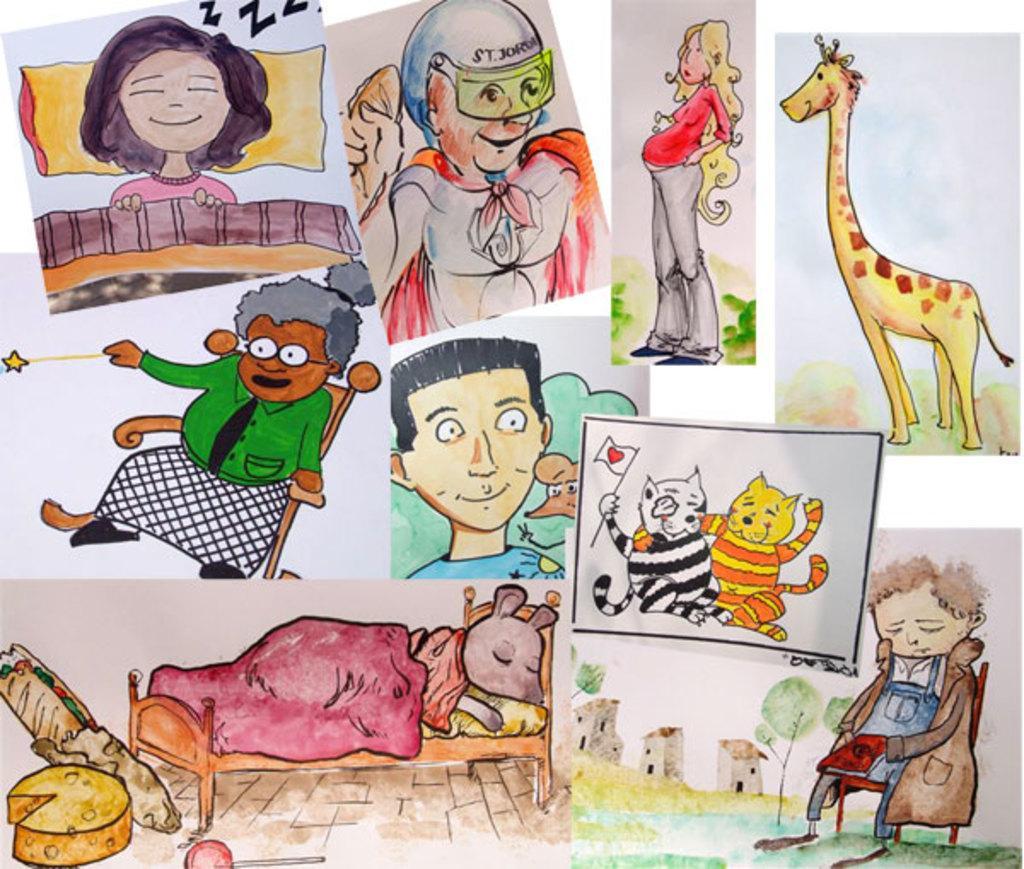Could you give a brief overview of what you see in this image? In this picture we can see cartoon images of people, animals, buildings, trees and some objects. 